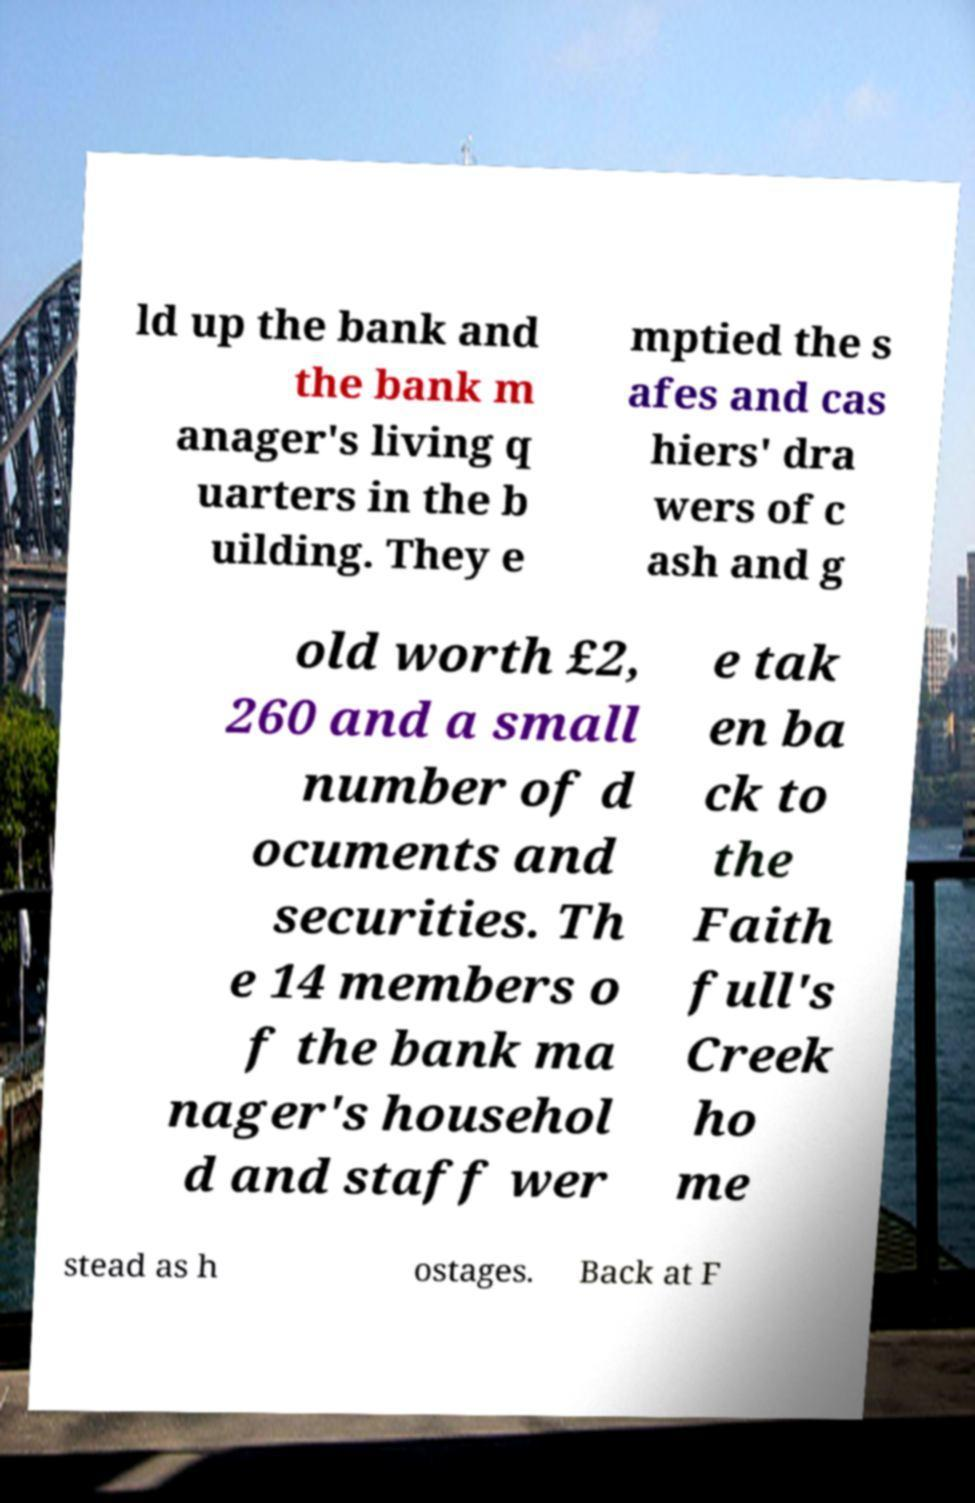Could you extract and type out the text from this image? ld up the bank and the bank m anager's living q uarters in the b uilding. They e mptied the s afes and cas hiers' dra wers of c ash and g old worth £2, 260 and a small number of d ocuments and securities. Th e 14 members o f the bank ma nager's househol d and staff wer e tak en ba ck to the Faith full's Creek ho me stead as h ostages. Back at F 